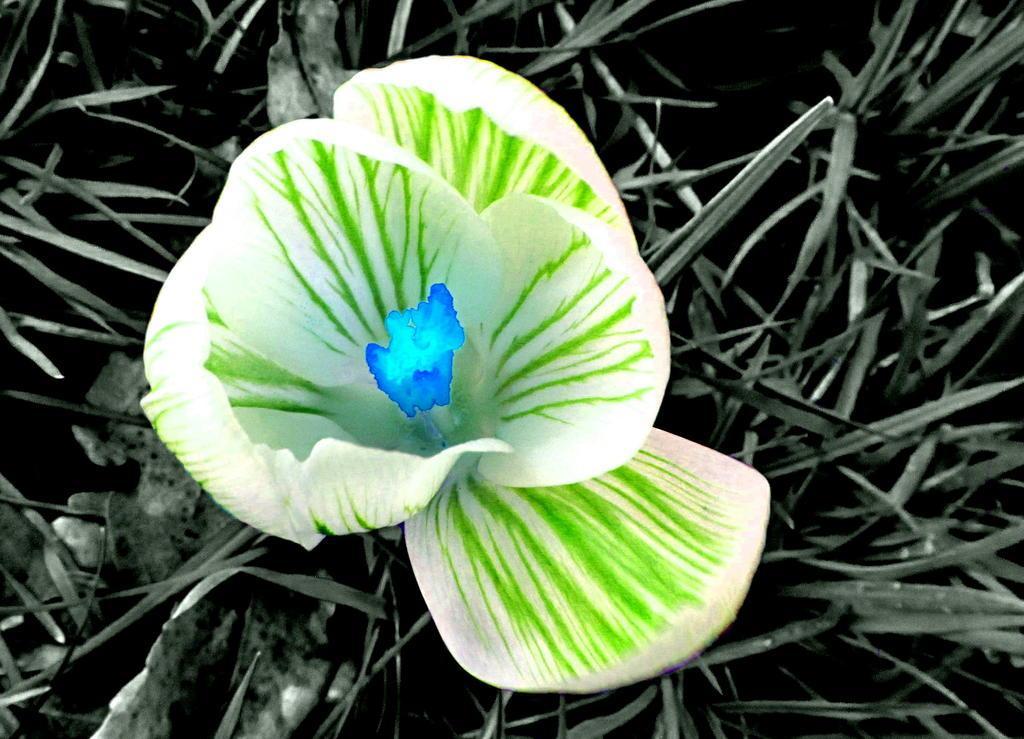Can you describe this image briefly? It looks like an edited image, we can see a flower and behind the flower there is grass. 